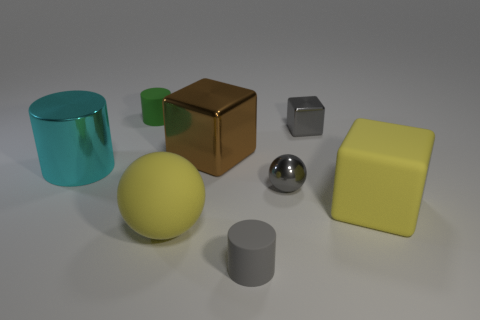Subtract all shiny blocks. How many blocks are left? 1 Add 2 big yellow things. How many objects exist? 10 Subtract all spheres. How many objects are left? 6 Subtract all yellow things. Subtract all blue blocks. How many objects are left? 6 Add 4 big yellow things. How many big yellow things are left? 6 Add 5 matte blocks. How many matte blocks exist? 6 Subtract 0 cyan spheres. How many objects are left? 8 